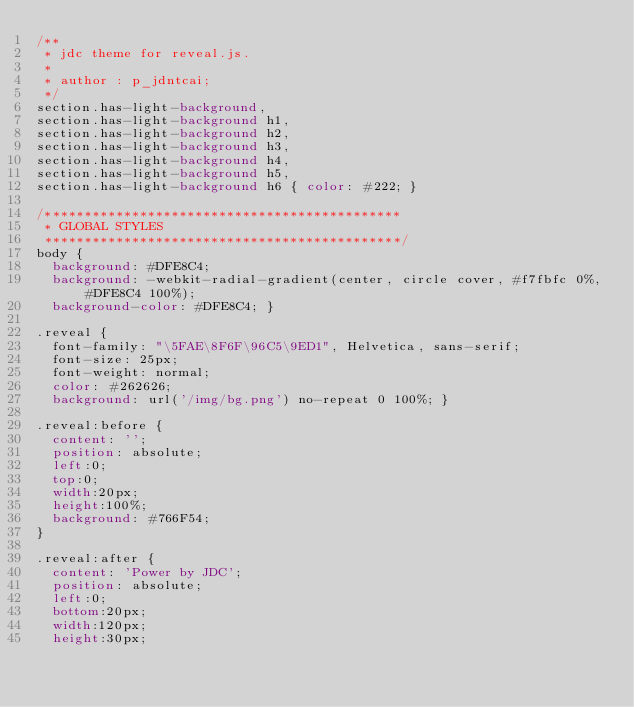Convert code to text. <code><loc_0><loc_0><loc_500><loc_500><_CSS_>/**
 * jdc theme for reveal.js.
 *
 * author : p_jdntcai;
 */
section.has-light-background, 
section.has-light-background h1, 
section.has-light-background h2, 
section.has-light-background h3, 
section.has-light-background h4, 
section.has-light-background h5, 
section.has-light-background h6 { color: #222; }

/*********************************************
 * GLOBAL STYLES
 *********************************************/
body {
  background: #DFE8C4;
  background: -webkit-radial-gradient(center, circle cover, #f7fbfc 0%, #DFE8C4 100%);
  background-color: #DFE8C4; }

.reveal {
  font-family: "\5FAE\8F6F\96C5\9ED1", Helvetica, sans-serif;
  font-size: 25px;
  font-weight: normal;
  color: #262626;
  background: url('/img/bg.png') no-repeat 0 100%; }

.reveal:before {
  content: '';
  position: absolute;
  left:0;
  top:0;
  width:20px;
  height:100%;
  background: #766F54;
}

.reveal:after {
  content: 'Power by JDC';
  position: absolute;
  left:0;
  bottom:20px;
  width:120px;
  height:30px;</code> 